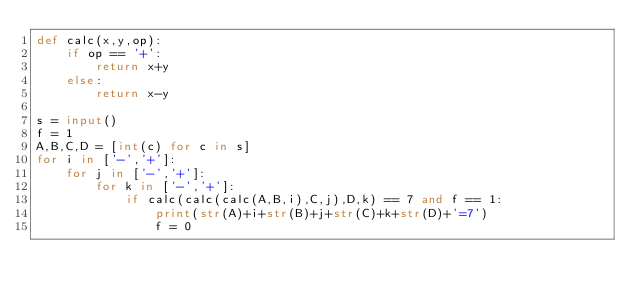Convert code to text. <code><loc_0><loc_0><loc_500><loc_500><_Python_>def calc(x,y,op):
    if op == '+':
        return x+y
    else:
        return x-y

s = input()
f = 1
A,B,C,D = [int(c) for c in s]
for i in ['-','+']:
    for j in ['-','+']:
        for k in ['-','+']:
            if calc(calc(calc(A,B,i),C,j),D,k) == 7 and f == 1:
                print(str(A)+i+str(B)+j+str(C)+k+str(D)+'=7')
                f = 0</code> 